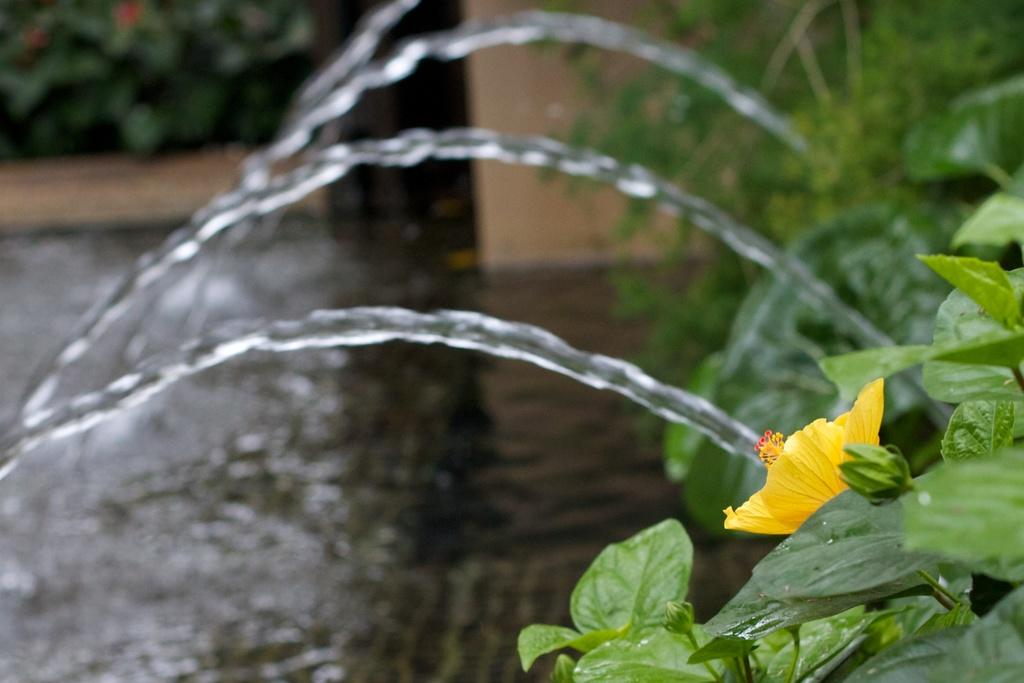What type of vegetation is on the right side of the image? There are plants and flowers on the right side of the image. What type of water feature is on the right side of the image? There is a fountain on the right side of the image. Can you describe the background of the image? The background of the image is blurred. What type of rake is being used to sense the patch of grass in the image? There is no rake or grass patch present in the image. 